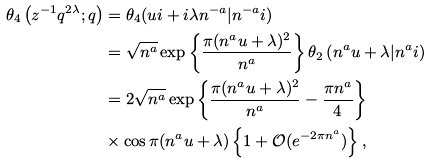<formula> <loc_0><loc_0><loc_500><loc_500>\theta _ { 4 } \left ( z ^ { - 1 } q ^ { 2 \lambda } ; q \right ) & = \theta _ { 4 } ( u i + i \lambda n ^ { - a } | n ^ { - a } i ) \\ & = \sqrt { n ^ { a } } \exp \left \{ \frac { \pi ( n ^ { a } u + \lambda ) ^ { 2 } } { n ^ { a } } \right \} \theta _ { 2 } \left ( n ^ { a } u + \lambda | n ^ { a } i \right ) \\ & = 2 \sqrt { n ^ { a } } \exp \left \{ \frac { \pi ( n ^ { a } u + \lambda ) ^ { 2 } } { n ^ { a } } - \frac { \pi n ^ { a } } { 4 } \right \} \\ & \times \cos \pi ( n ^ { a } u + \lambda ) \left \{ 1 + \mathcal { O } ( e ^ { - 2 \pi n ^ { a } } ) \right \} ,</formula> 